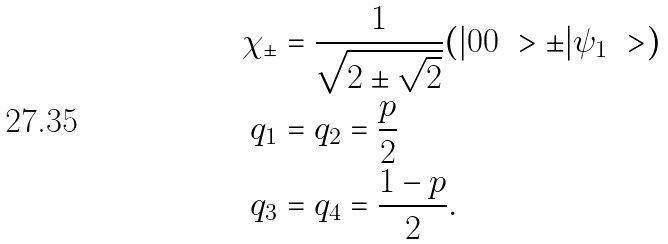Convert formula to latex. <formula><loc_0><loc_0><loc_500><loc_500>\chi _ { \pm } & = \frac { 1 } { \sqrt { 2 \pm \sqrt { 2 } } } ( | 0 0 \ > \pm | \psi _ { 1 } \ > ) \\ q _ { 1 } & = q _ { 2 } = \frac { p } { 2 } \\ q _ { 3 } & = q _ { 4 } = \frac { 1 - p } { 2 } .</formula> 